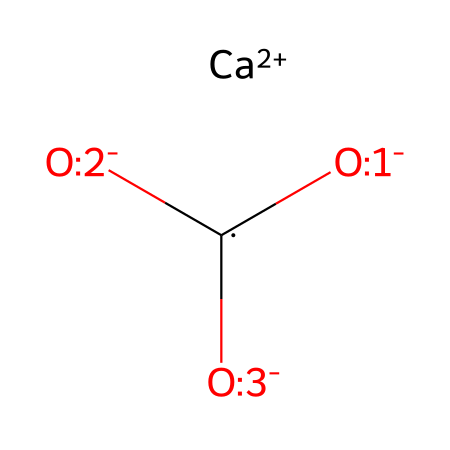What is the oxidation state of calcium in this compound? Calcium is represented as [Ca+2] in the SMILES notation, indicating it has an oxidation state of +2.
Answer: +2 How many oxygen atoms are in this chemical? The structure shows three oxygen atoms in the representation: [O-:1], [O-:2], and [O-:3].
Answer: 3 What is the overall charge of this coordination compound? The calcium ion contributes a charge of +2, and the three oxygen atoms are negatively charged ([O-]), contributing -3, which gives an overall charge of -1.
Answer: -1 Which element serves as the central atom in this structure? In coordination compounds, the central atom is typically a metal, and in this case, calcium is the central atom represented as [Ca+2].
Answer: calcium What type of bonding is likely present in this compound? The presence of coordination between calcium and the oxygen atoms suggests ionic bonding, typical in coordination compounds that contain charged species.
Answer: ionic How many coordinate bonds does calcium form in this compound? Calcium, being the central atom, is likely to be bonded to the three oxygen atoms, resulting in three coordinate bonds.
Answer: 3 